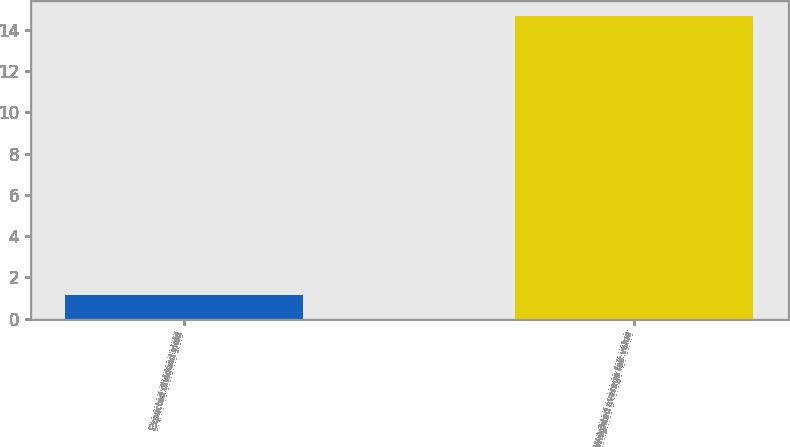Convert chart. <chart><loc_0><loc_0><loc_500><loc_500><bar_chart><fcel>Expected dividend yield<fcel>Weighted average fair value<nl><fcel>1.12<fcel>14.66<nl></chart> 